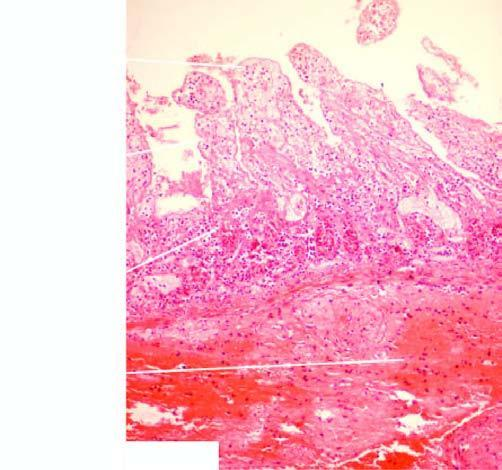what does the mucosa in the infarcted area show?
Answer the question using a single word or phrase. Coagulative necrosis and submucosal haemorrhages 